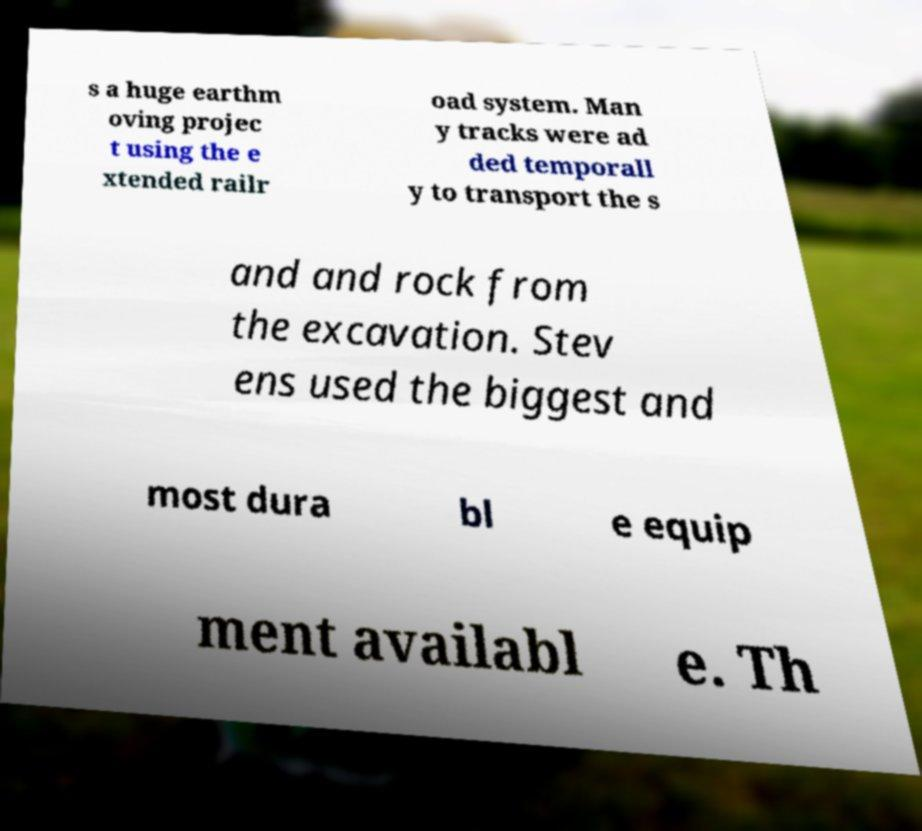Please identify and transcribe the text found in this image. s a huge earthm oving projec t using the e xtended railr oad system. Man y tracks were ad ded temporall y to transport the s and and rock from the excavation. Stev ens used the biggest and most dura bl e equip ment availabl e. Th 